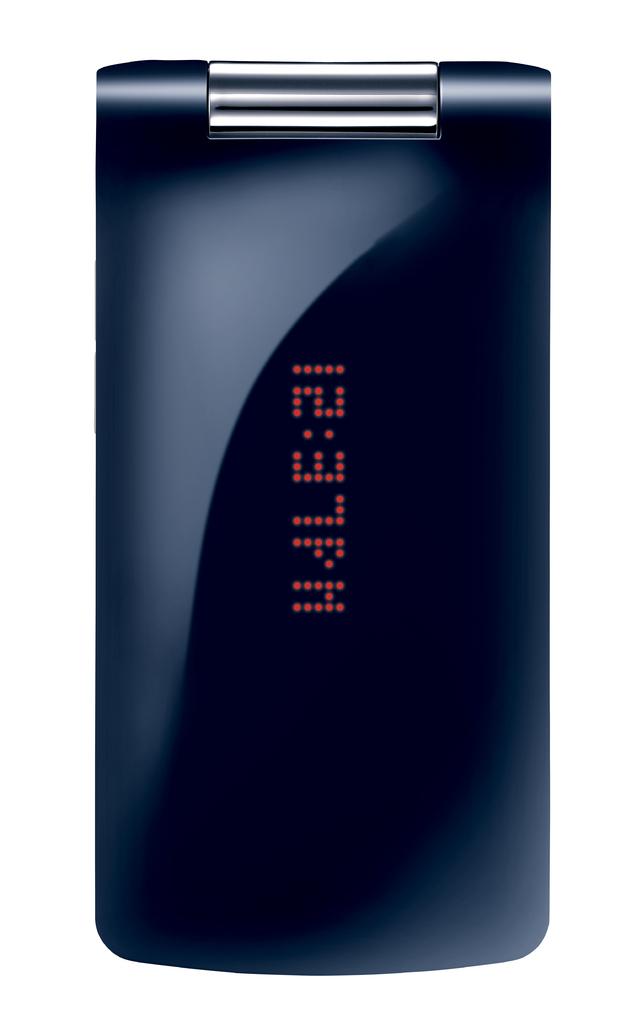What time is being displayed?
Offer a very short reply. 12:37 pm. 